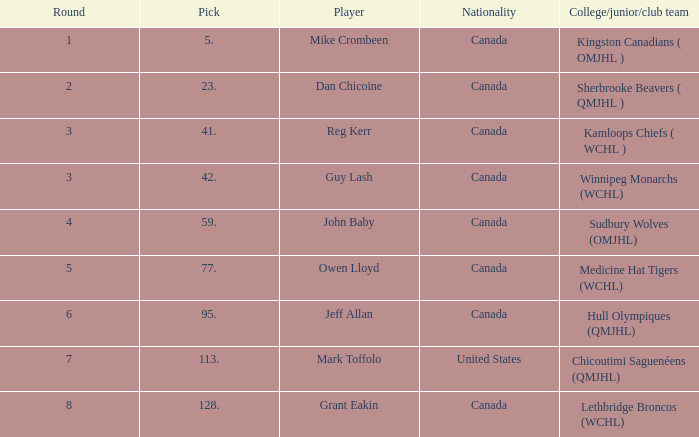Which Round has a Player of dan chicoine, and a Pick larger than 23? None. 